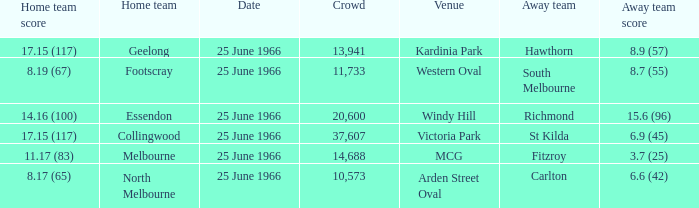Where did the away team score 8.7 (55)? Western Oval. Parse the full table. {'header': ['Home team score', 'Home team', 'Date', 'Crowd', 'Venue', 'Away team', 'Away team score'], 'rows': [['17.15 (117)', 'Geelong', '25 June 1966', '13,941', 'Kardinia Park', 'Hawthorn', '8.9 (57)'], ['8.19 (67)', 'Footscray', '25 June 1966', '11,733', 'Western Oval', 'South Melbourne', '8.7 (55)'], ['14.16 (100)', 'Essendon', '25 June 1966', '20,600', 'Windy Hill', 'Richmond', '15.6 (96)'], ['17.15 (117)', 'Collingwood', '25 June 1966', '37,607', 'Victoria Park', 'St Kilda', '6.9 (45)'], ['11.17 (83)', 'Melbourne', '25 June 1966', '14,688', 'MCG', 'Fitzroy', '3.7 (25)'], ['8.17 (65)', 'North Melbourne', '25 June 1966', '10,573', 'Arden Street Oval', 'Carlton', '6.6 (42)']]} 